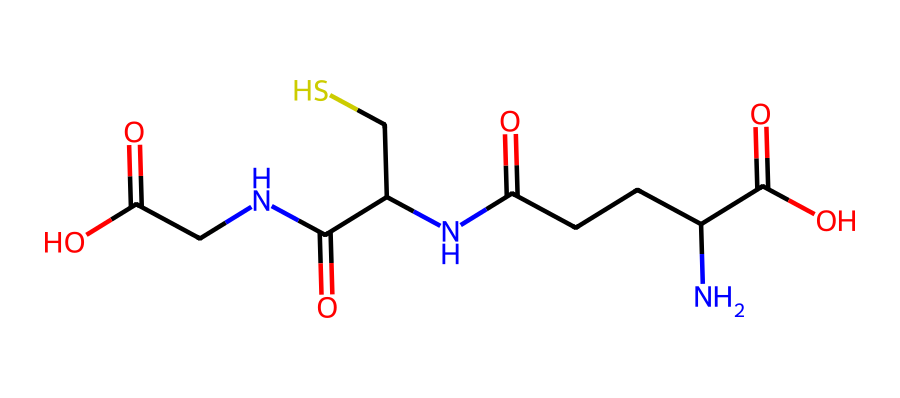What is the chemical name of the compound represented by this SMILES? The SMILES provided corresponds to glutathione, which is a tripeptide composed of three amino acids: glutamate, cysteine, and glycine.
Answer: glutathione How many sulfur atoms are present in this molecule? By analyzing the structure coded in the SMILES, there is one sulfur atom indicated by the "S" in the "C(CS)" portion, representing cysteine.
Answer: one What type of functional groups can be identified in this compound? The chemical structure contains several functional groups: carboxylic acids (C(=O)O), amides (C(=O)N), and a thiol group (C(S)).
Answer: carboxylic acids, amides, thiol What is the total number of carbon atoms in this molecule? By counting the carbon atoms represented in the SMILES notation, we can identify a total of 10 carbon atoms.
Answer: ten What role does the sulfur atom play in glutathione's function as an antioxidant? The sulfur atom is part of the thiol group (-SH) in cysteine, which is responsible for forming disulfide bonds, crucial for antioxidant activity.
Answer: antioxidant activity How many amide linkages are present in this molecule? The structure shows two instances where the carbonyl (C=O) is bonded to nitrogen (N), indicating two amide linkages in glutathione.
Answer: two 